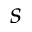<formula> <loc_0><loc_0><loc_500><loc_500>s</formula> 